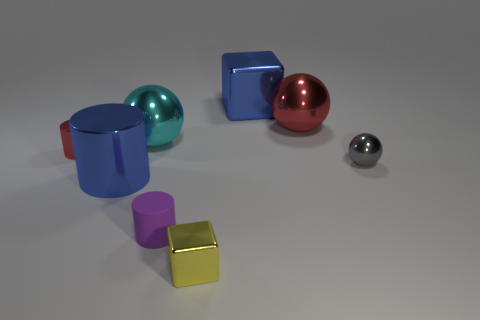Add 2 blue metallic things. How many objects exist? 10 Subtract all metal cylinders. How many cylinders are left? 1 Subtract 2 blocks. How many blocks are left? 0 Subtract all red balls. Subtract all brown cylinders. How many balls are left? 2 Subtract all cyan balls. How many purple blocks are left? 0 Subtract all blue rubber objects. Subtract all tiny red cylinders. How many objects are left? 7 Add 1 tiny red things. How many tiny red things are left? 2 Add 6 big balls. How many big balls exist? 8 Subtract all gray spheres. How many spheres are left? 2 Subtract 0 green cubes. How many objects are left? 8 